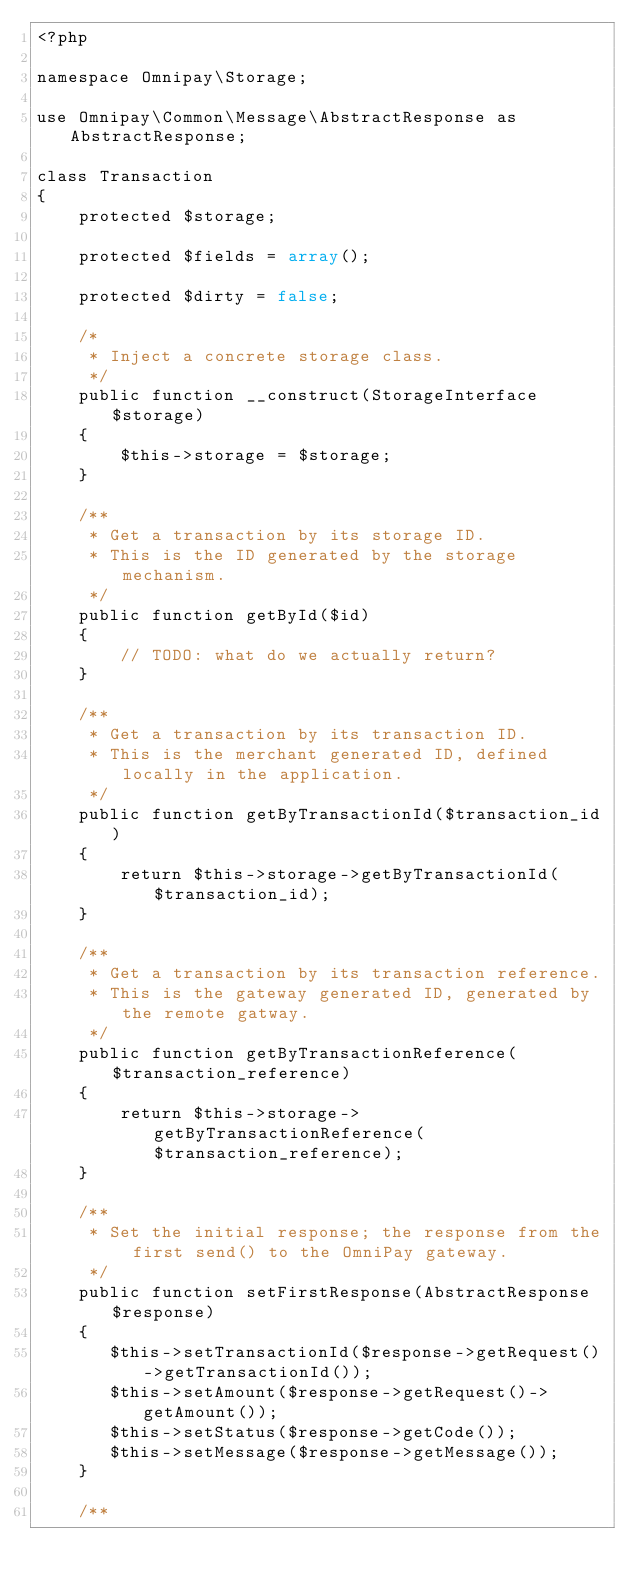Convert code to text. <code><loc_0><loc_0><loc_500><loc_500><_PHP_><?php

namespace Omnipay\Storage;

use Omnipay\Common\Message\AbstractResponse as AbstractResponse;

class Transaction
{
    protected $storage;

    protected $fields = array();

    protected $dirty = false;

    /*
     * Inject a concrete storage class.
     */
    public function __construct(StorageInterface $storage)
    {
        $this->storage = $storage;
    }

    /**
     * Get a transaction by its storage ID.
     * This is the ID generated by the storage mechanism.
     */
    public function getById($id)
    {
        // TODO: what do we actually return?
    }

    /**
     * Get a transaction by its transaction ID.
     * This is the merchant generated ID, defined locally in the application.
     */
    public function getByTransactionId($transaction_id)
    {
        return $this->storage->getByTransactionId($transaction_id);
    }

    /**
     * Get a transaction by its transaction reference.
     * This is the gateway generated ID, generated by the remote gatway.
     */
    public function getByTransactionReference($transaction_reference)
    {
        return $this->storage->getByTransactionReference($transaction_reference);
    }

    /**
     * Set the initial response; the response from the first send() to the OmniPay gateway.
     */
    public function setFirstResponse(AbstractResponse $response)
    {
       $this->setTransactionId($response->getRequest()->getTransactionId());
       $this->setAmount($response->getRequest()->getAmount());
       $this->setStatus($response->getCode());
       $this->setMessage($response->getMessage());
    }

    /**</code> 